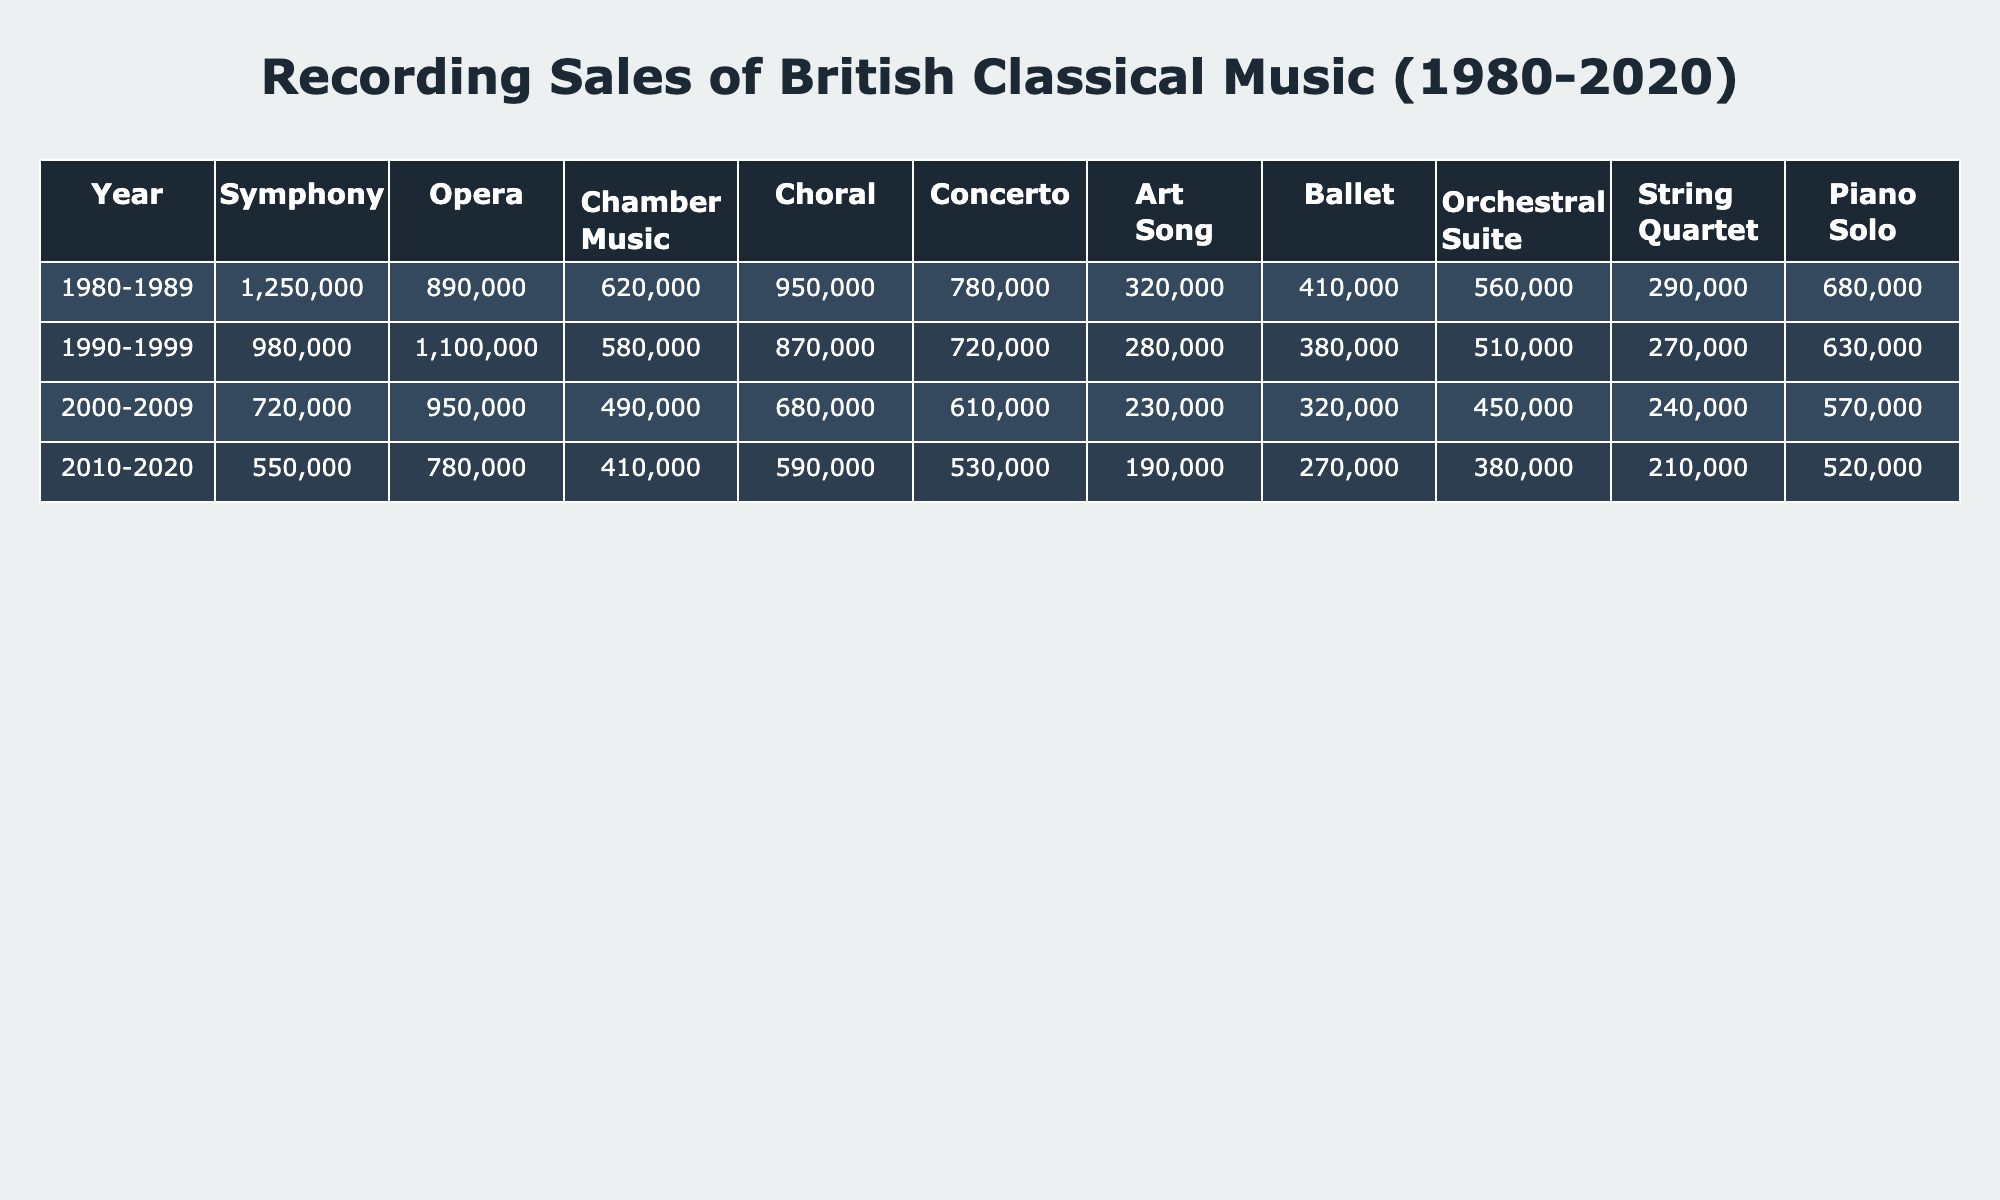What was the highest selling genre of British classical music in the 1980s? In the 1980s, the genre with the highest sales is Symphony, which sold 1,250,000 copies.
Answer: Symphony Which genre had the lowest sales in the decade 2010-2020? According to the data for 2010-2020, the genre with the lowest sales was Chamber Music, with 410,000 copies sold.
Answer: Chamber Music How much did Choral music sell in total from 1980 to 2020? To find the total sales for Choral music, add the sales for each decade: 950,000 (1980-1989) + 870,000 (1990-1999) + 680,000 (2000-2009) + 590,000 (2010-2020) = 3,090,000.
Answer: 3,090,000 What was the trend in sales for Chamber Music from the 1980s to the 2010s? The sales of Chamber Music decreased from 620,000 in the 1980s to 410,000 in the 2010s, showing a downward trend over the decades.
Answer: Downward trend Did sales for Opera music ever exceed 1 million during the studied periods? Yes, during the 1990-1999 period, Opera music sales exceeded 1 million, reaching 1,100,000 copies.
Answer: Yes Which genre had the largest decline in sales from the 1980-1989 decade to the 2010-2020 decade? By comparing the sales figures, we see that the largest decline is in the genre of Symphony, which went from 1,250,000 in the 1980s to 550,000 in the 2010s. This equates to a decline of 700,000 copies.
Answer: Symphony What was the average annual sales of Art Song from 1980 to 2020? To calculate the average annual sales of Art Song, first sum the sales: 320,000 + 280,000 + 230,000 + 190,000 = 1,020,000. Then divide by 4 decades, giving an average of 1,020,000 / 4 = 255,000.
Answer: 255,000 True or False: The sales of Concerto music increased from the 1990s to the 2000s. Looking at the sales figures, Concerto music sold 720,000 in the 1990s and decreased to 610,000 in the 2000s indicating a decline, therefore this statement is false.
Answer: False Which genre had a consistent decrease in sales over the decades? By examining the data, Chamber Music shows consistent decreases from 620,000 (1980-1989) to 410,000 (2010-2020), reflecting a downward pattern across all decades.
Answer: Chamber Music 